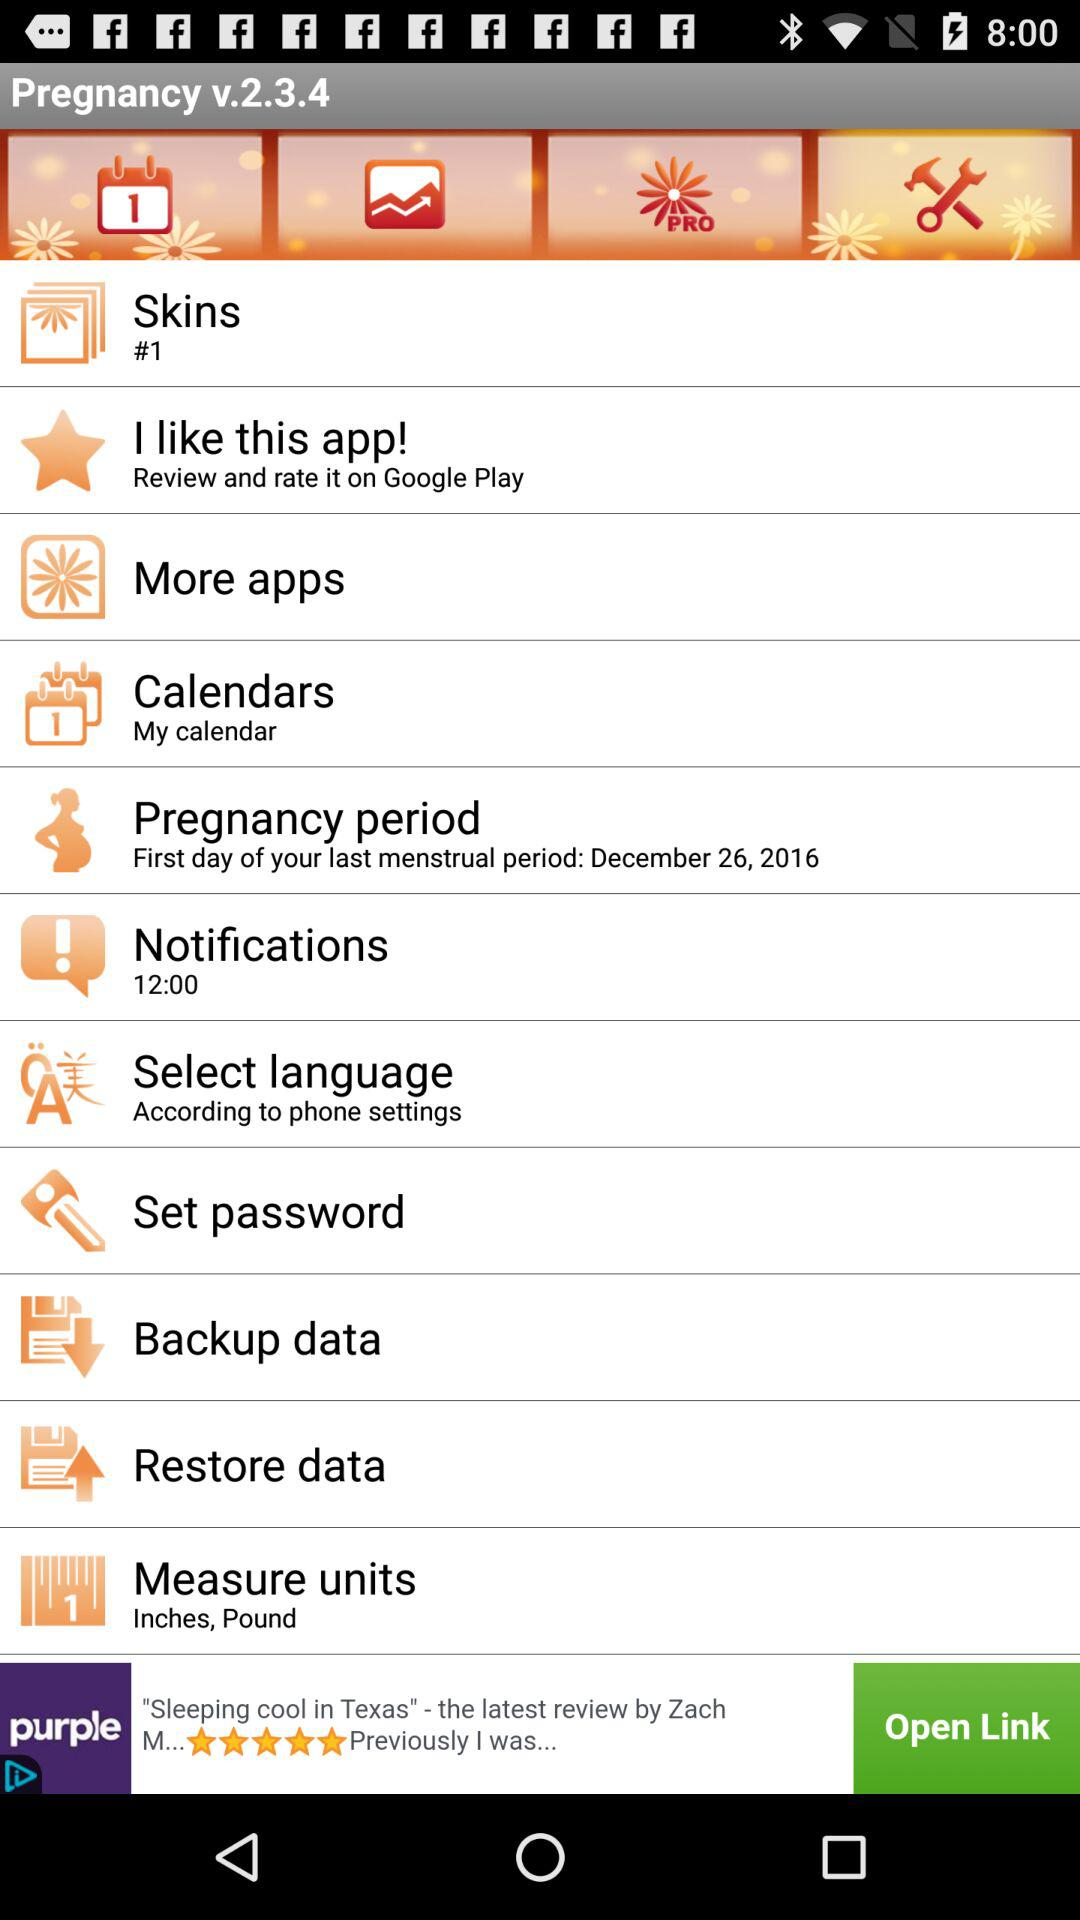Where will applications be rated and reviewed by users? The applications will be rated and reviewed on Google Play. 